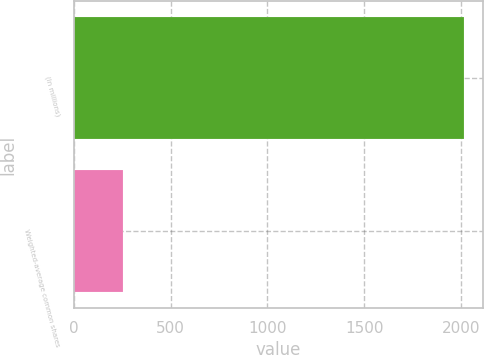Convert chart to OTSL. <chart><loc_0><loc_0><loc_500><loc_500><bar_chart><fcel>(In millions)<fcel>Weighted-average common shares<nl><fcel>2014<fcel>252.7<nl></chart> 